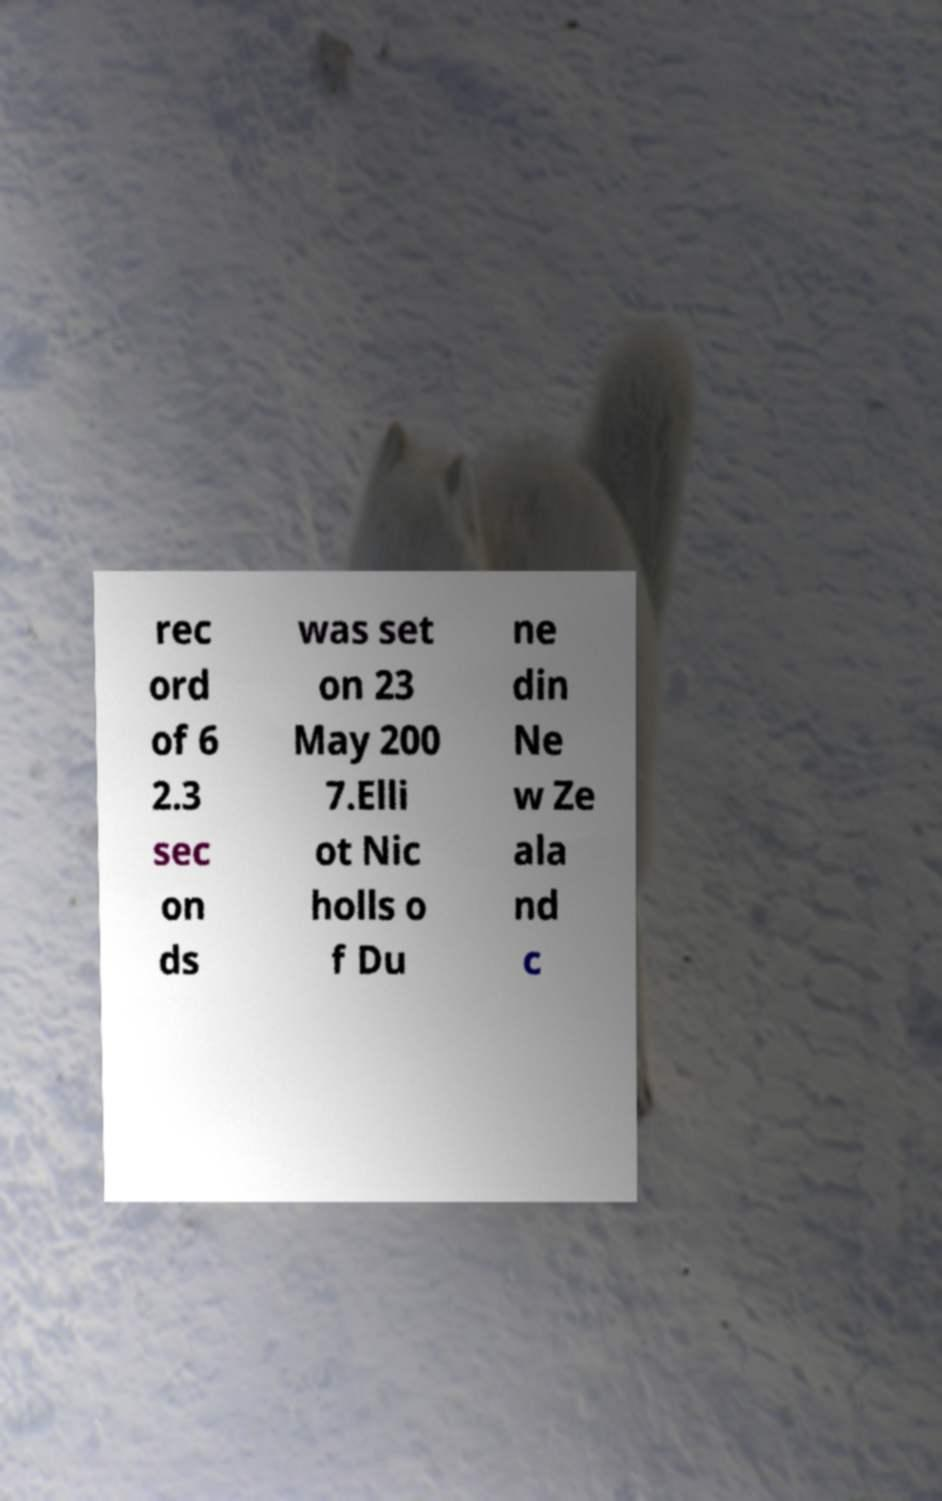Could you extract and type out the text from this image? rec ord of 6 2.3 sec on ds was set on 23 May 200 7.Elli ot Nic holls o f Du ne din Ne w Ze ala nd c 